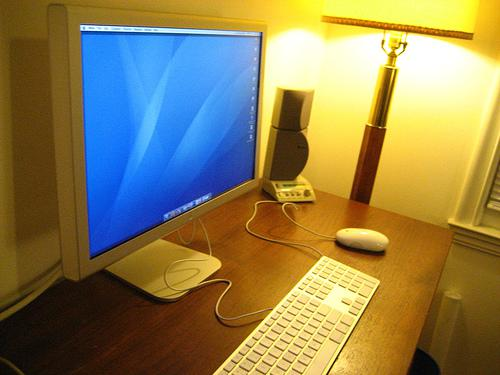Question: what color are the walls?
Choices:
A. Grey.
B. White.
C. Yellow.
D. Black.
Answer with the letter. Answer: B Question: what material is the table made of?
Choices:
A. Metal.
B. Plastic.
C. Wood.
D. Cement.
Answer with the letter. Answer: C Question: what color is the background of the computer?
Choices:
A. Black.
B. White.
C. Brown.
D. Blue.
Answer with the letter. Answer: D Question: how many items are in the computer's tray on the bottom of the screen?
Choices:
A. Eleven.
B. Ten.
C. Twelve.
D. Nine.
Answer with the letter. Answer: C 